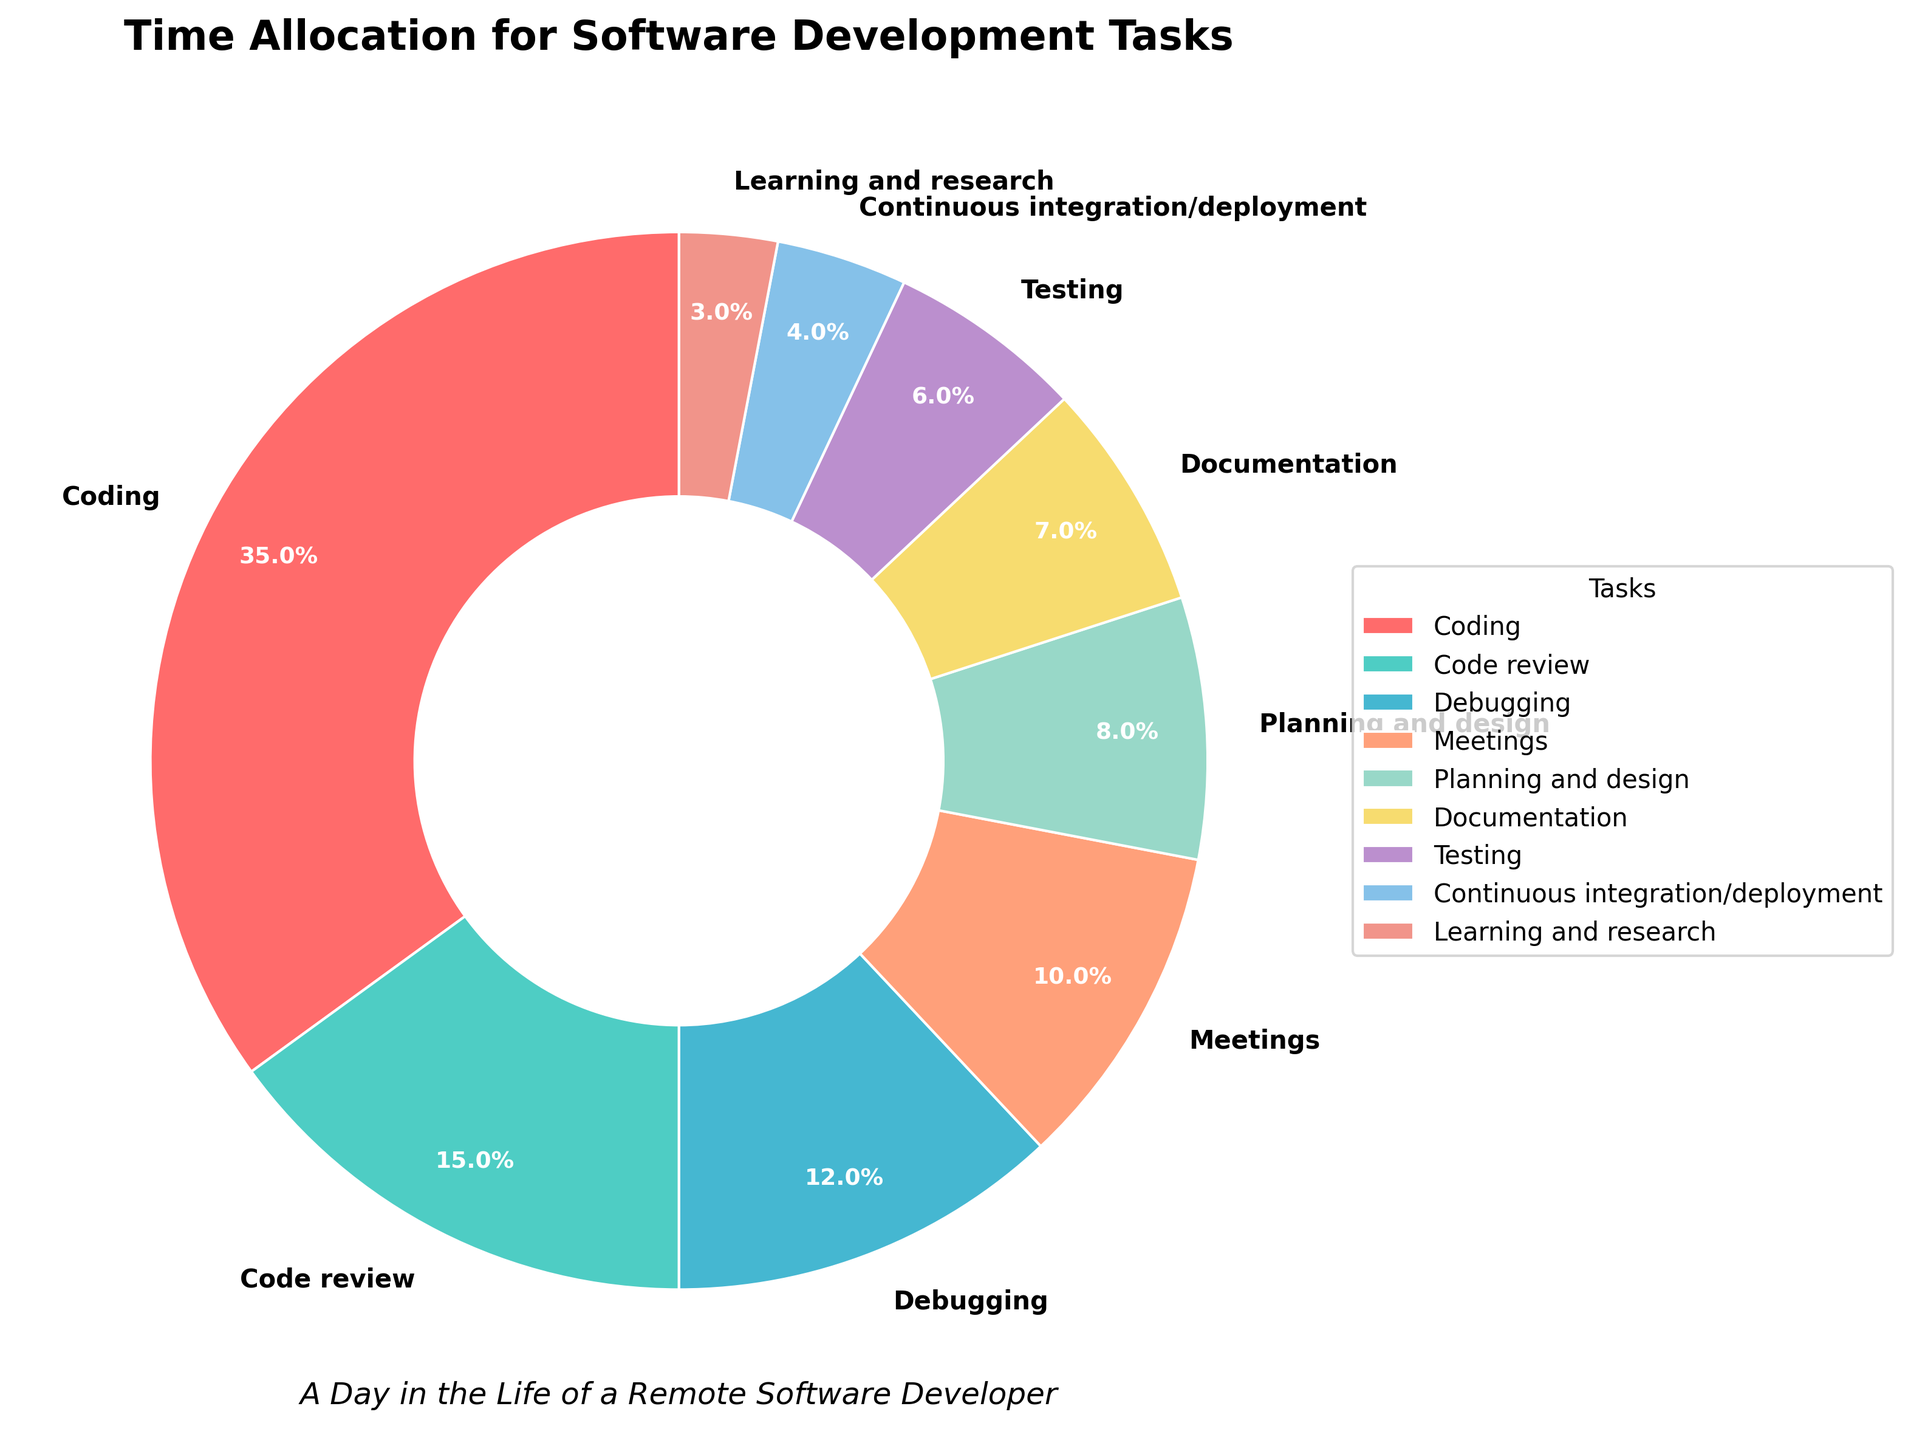What's the task that takes up the most time? The task percentages are given, and the highest percentage represents the task that takes up the most time. Coding occupies 35%, which is the largest.
Answer: Coding How much more time is spent on Coding than on Testing? Coding takes 35% of time and Testing takes 6%. Subtracting these gives 35% - 6% = 29%.
Answer: 29% Are there any tasks that occupy exactly one-third (33.33%) of the total time? Examine the percentages for each task. None of the provided tasks have a percentage of exactly one-third of the total time.
Answer: No Which task uses the least amount of time and what is its percentage? Reviewing the pie chart segments, Learning and research is the smallest segment at 3%.
Answer: Learning and research, 3% Are Meetings more time-consuming than Documentation? Compare the percentage of Meetings (10%) with Documentation (7%). Meetings take up a larger percentage of the time.
Answer: Yes What’s the total percentage of time spent on Code review, Documentation, and Testing combined? Add the percentages for these tasks: Code review (15%), Documentation (7%), and Testing (6%). The total is 15% + 7% + 6% = 28%.
Answer: 28% How does the time spent on Continuous integration/deployment compare to Debugging? Continuous integration/deployment takes 4% and Debugging takes 12%. Therefore, Debugging takes more time.
Answer: Debugging takes 8% more What is the difference in time allocation between Planning and design, and Meetings? Planning and design take 8% and Meetings take 10%. The difference is 10% - 8% = 2%.
Answer: 2% Among all non-direct programming activities (excluding Coding), which one takes the most time? Excluding Coding (35%), the largest remaining percentage is Code review at 15%.
Answer: Code review How much total time is spent on activities related to quality assurance (Testing and Debugging)? Add the percentages for Testing (6%) and Debugging (12%). The total is 6% + 12% = 18%.
Answer: 18% 